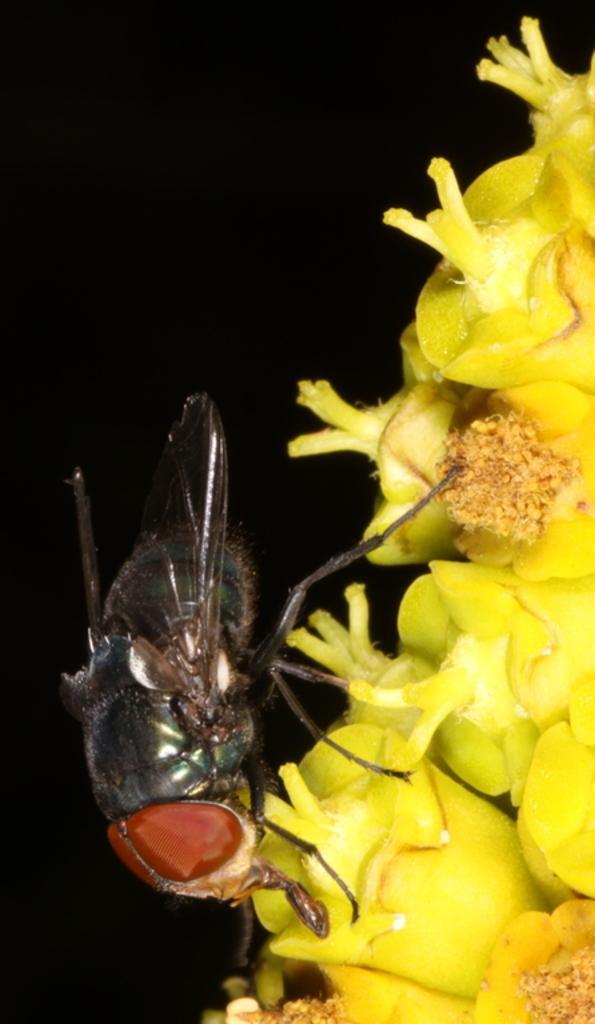Could you give a brief overview of what you see in this image? In this image I can see an insect on the flower and the insect is in black and brown color, and the flower is in yellow color. I can see dark background. 